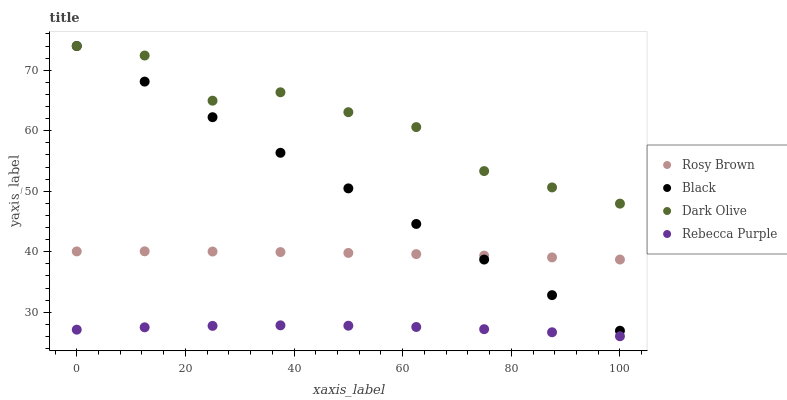Does Rebecca Purple have the minimum area under the curve?
Answer yes or no. Yes. Does Dark Olive have the maximum area under the curve?
Answer yes or no. Yes. Does Rosy Brown have the minimum area under the curve?
Answer yes or no. No. Does Rosy Brown have the maximum area under the curve?
Answer yes or no. No. Is Black the smoothest?
Answer yes or no. Yes. Is Dark Olive the roughest?
Answer yes or no. Yes. Is Rosy Brown the smoothest?
Answer yes or no. No. Is Rosy Brown the roughest?
Answer yes or no. No. Does Rebecca Purple have the lowest value?
Answer yes or no. Yes. Does Rosy Brown have the lowest value?
Answer yes or no. No. Does Black have the highest value?
Answer yes or no. Yes. Does Rosy Brown have the highest value?
Answer yes or no. No. Is Rebecca Purple less than Black?
Answer yes or no. Yes. Is Dark Olive greater than Rebecca Purple?
Answer yes or no. Yes. Does Dark Olive intersect Black?
Answer yes or no. Yes. Is Dark Olive less than Black?
Answer yes or no. No. Is Dark Olive greater than Black?
Answer yes or no. No. Does Rebecca Purple intersect Black?
Answer yes or no. No. 